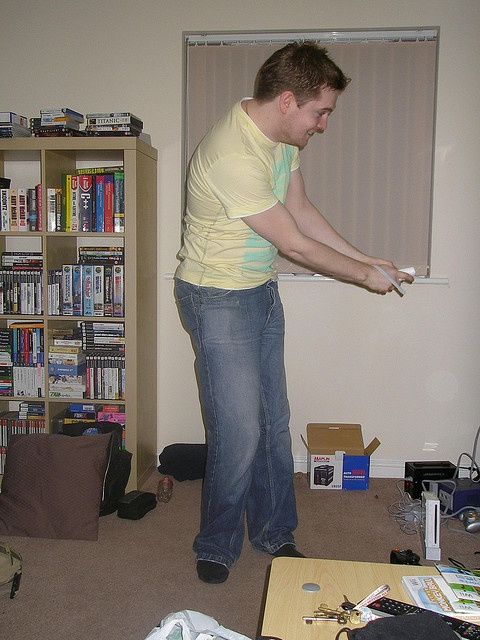Describe the objects in this image and their specific colors. I can see people in gray, darkgray, black, and tan tones, book in gray, darkgray, black, and tan tones, book in gray, black, darkgray, and maroon tones, remote in gray, black, darkgray, and maroon tones, and book in gray, black, darkgray, and purple tones in this image. 